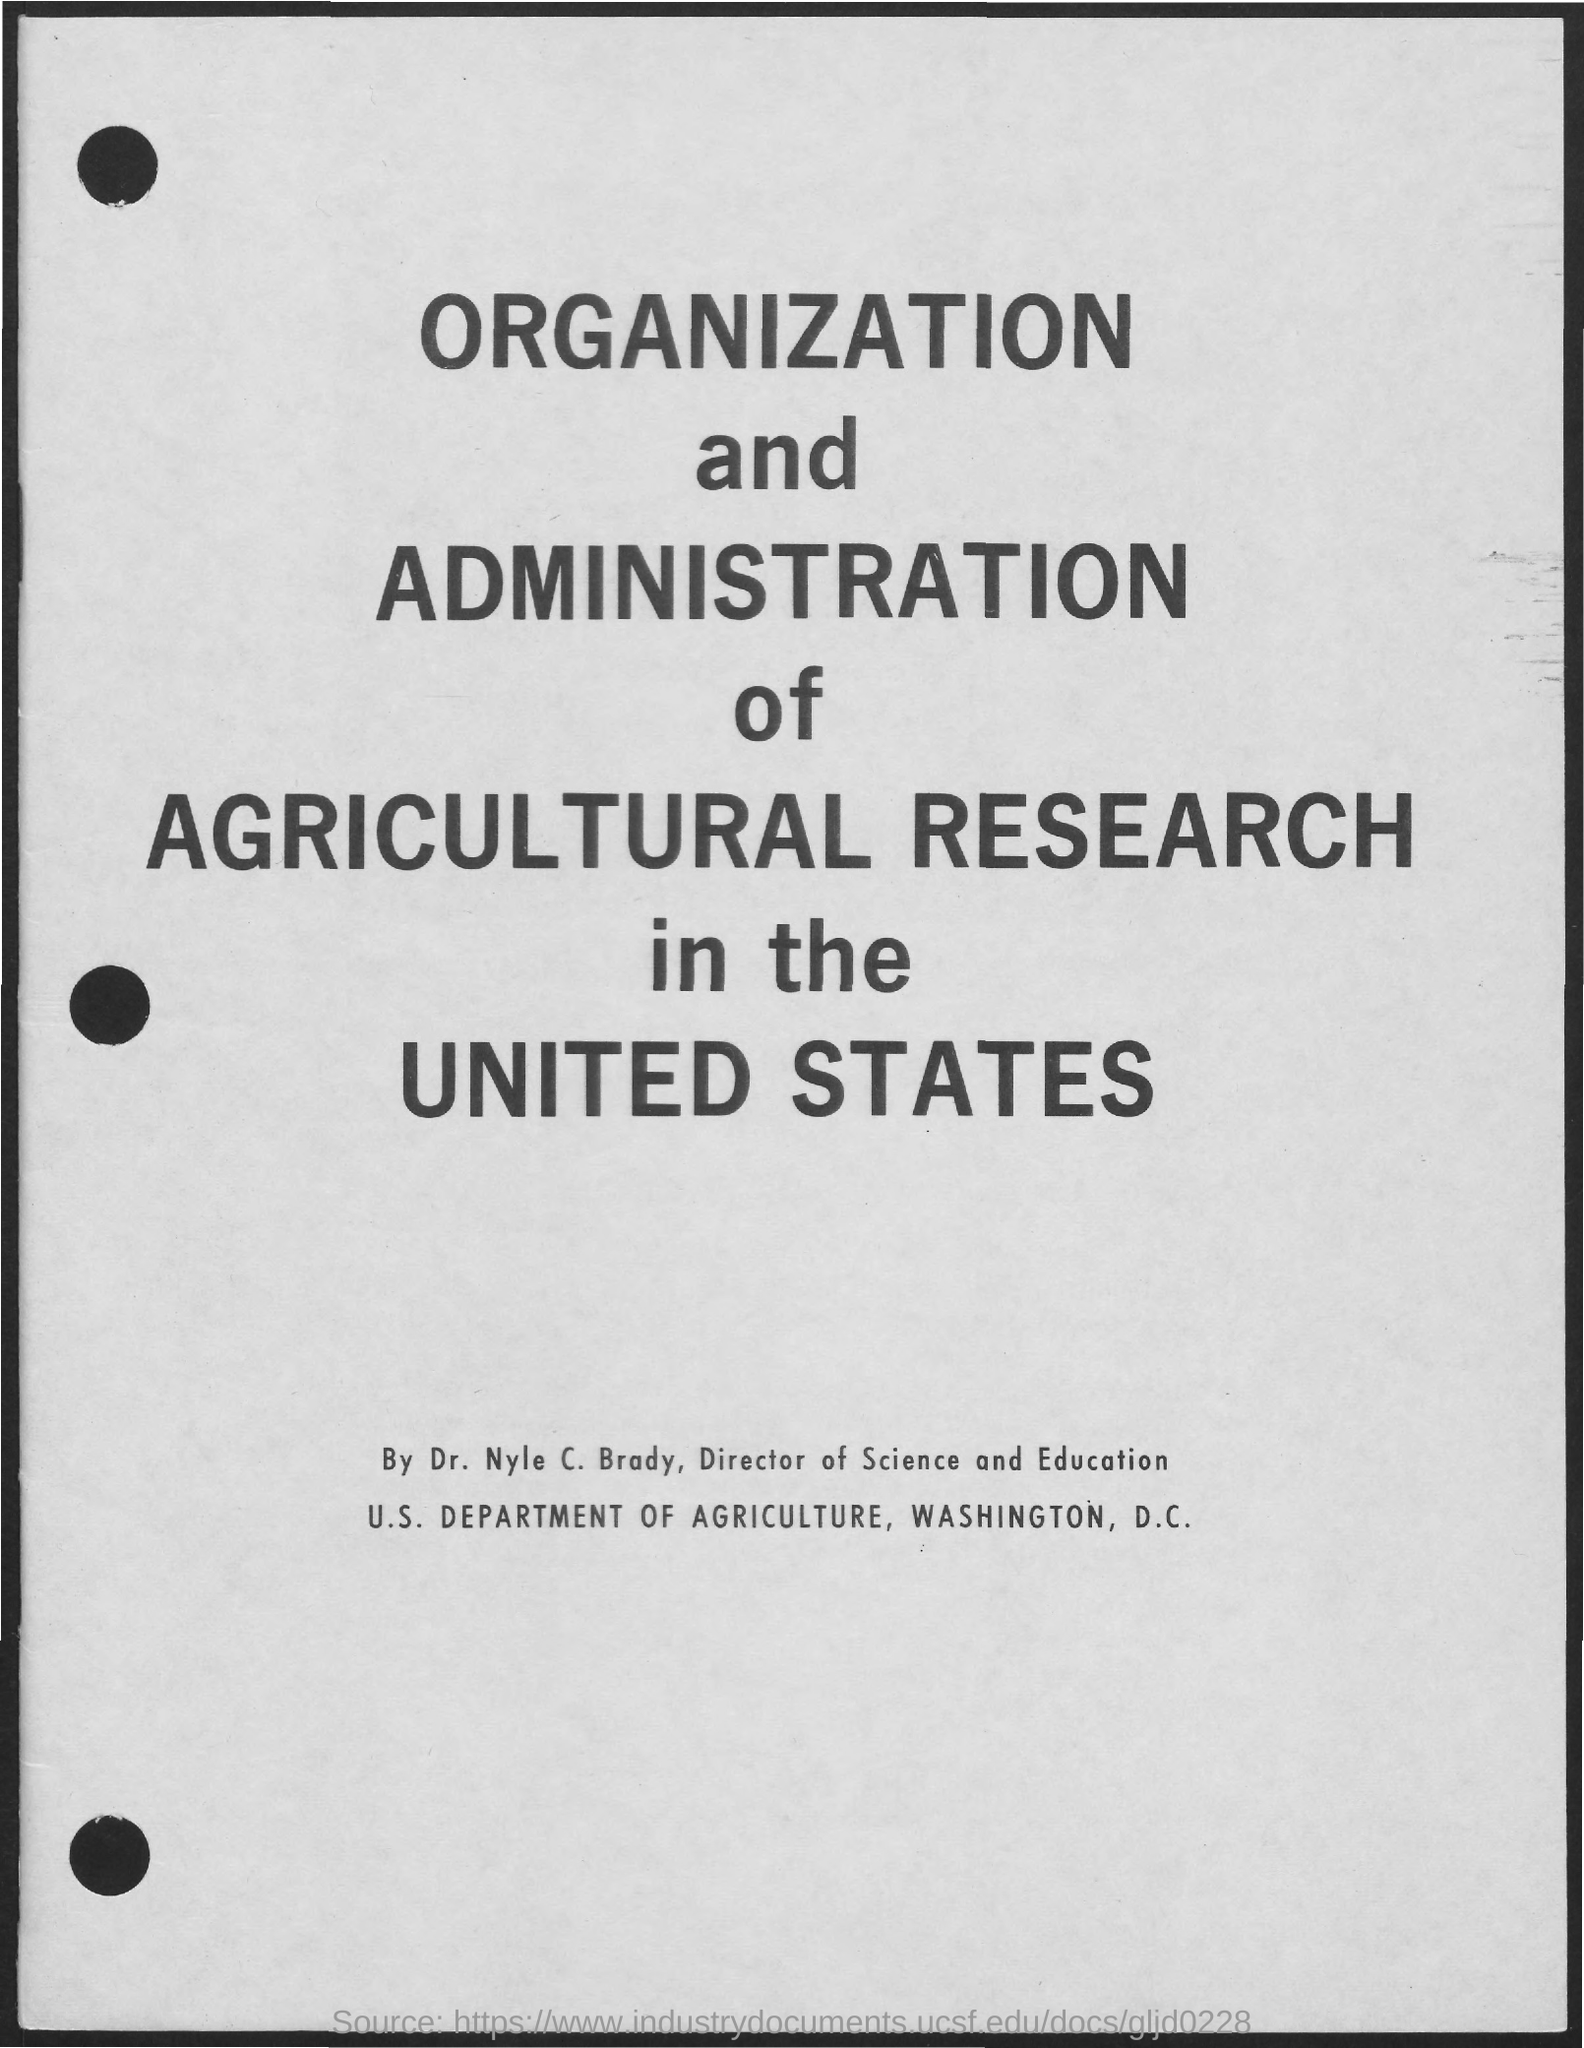Highlight a few significant elements in this photo. It is Dr. Nyle C. Brady who serves as the director of Science and Education. The U.S. Department of Agriculture is located in Washington, D.C. 